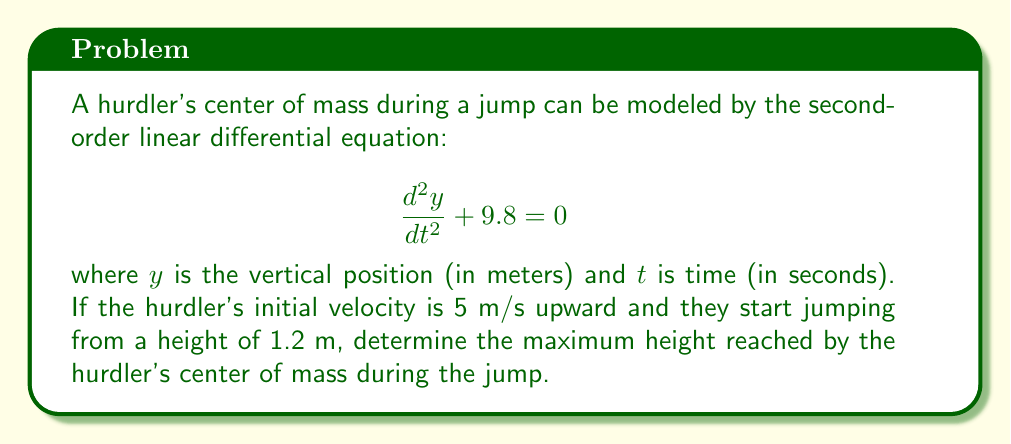Can you answer this question? To solve this problem, we need to follow these steps:

1) First, we need to solve the differential equation. The general solution is:

   $$y(t) = -4.9t^2 + C_1t + C_2$$

2) We have two initial conditions:
   - Initial velocity: $\frac{dy}{dt}(0) = 5$ m/s
   - Initial height: $y(0) = 1.2$ m

3) To find $C_1$, we differentiate $y(t)$ and use the initial velocity condition:

   $$\frac{dy}{dt} = -9.8t + C_1$$
   $$5 = -9.8(0) + C_1$$
   $$C_1 = 5$$

4) To find $C_2$, we use the initial height condition:

   $$1.2 = -4.9(0)^2 + 5(0) + C_2$$
   $$C_2 = 1.2$$

5) Therefore, the particular solution is:

   $$y(t) = -4.9t^2 + 5t + 1.2$$

6) To find the maximum height, we need to find where $\frac{dy}{dt} = 0$:

   $$\frac{dy}{dt} = -9.8t + 5 = 0$$
   $$t = \frac{5}{9.8} \approx 0.51 \text{ seconds}$$

7) We can now substitute this time back into our equation for $y(t)$:

   $$y(0.51) = -4.9(0.51)^2 + 5(0.51) + 1.2$$
   $$\approx -1.27 + 2.55 + 1.2$$
   $$\approx 2.48 \text{ meters}$$
Answer: The maximum height reached by the hurdler's center of mass during the jump is approximately 2.48 meters. 